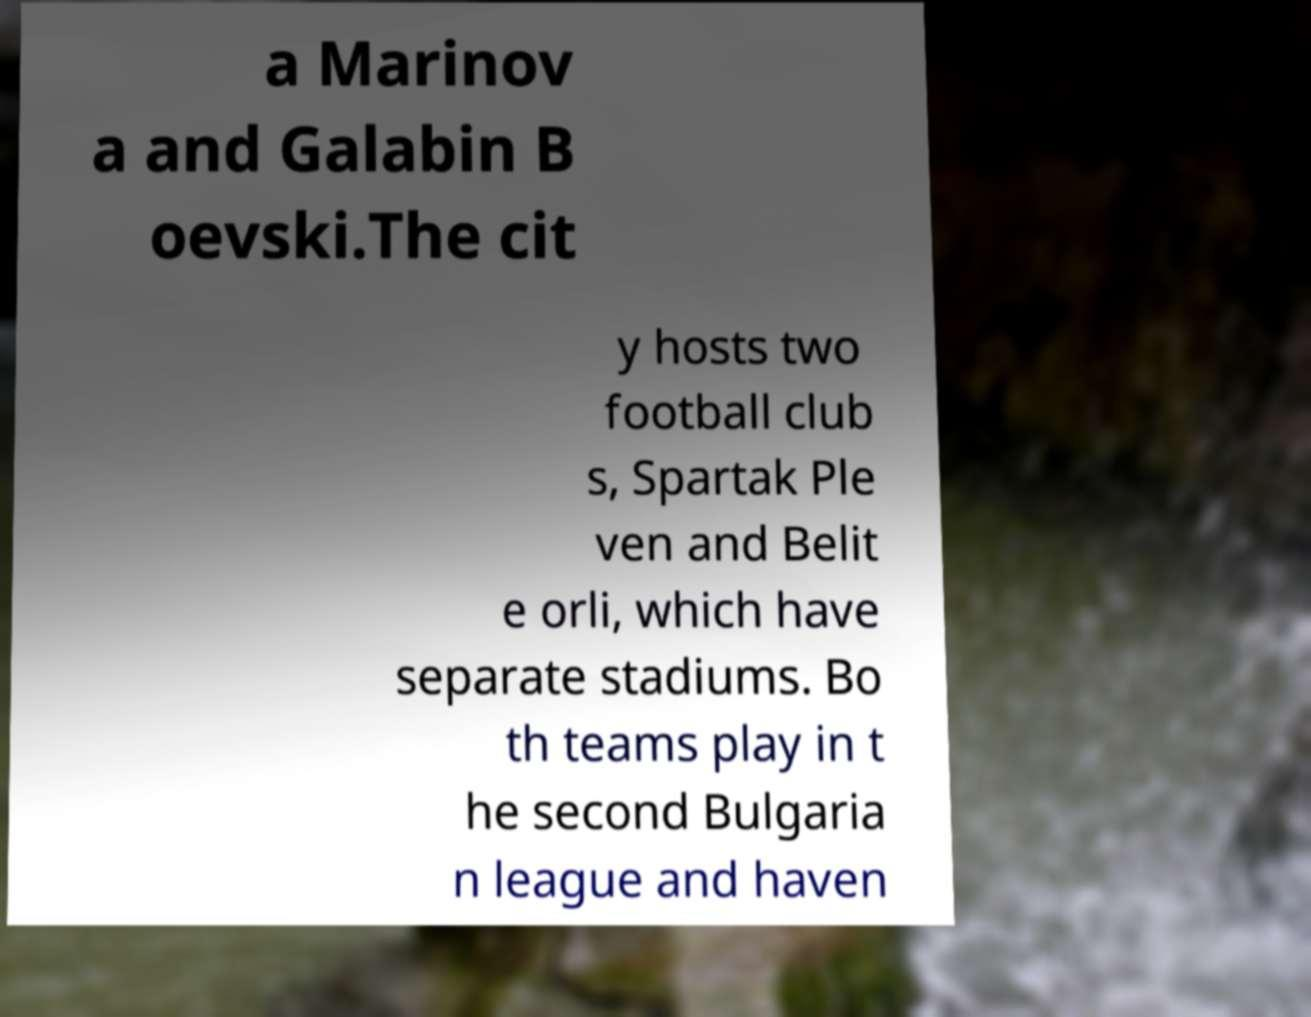What messages or text are displayed in this image? I need them in a readable, typed format. a Marinov a and Galabin B oevski.The cit y hosts two football club s, Spartak Ple ven and Belit e orli, which have separate stadiums. Bo th teams play in t he second Bulgaria n league and haven 